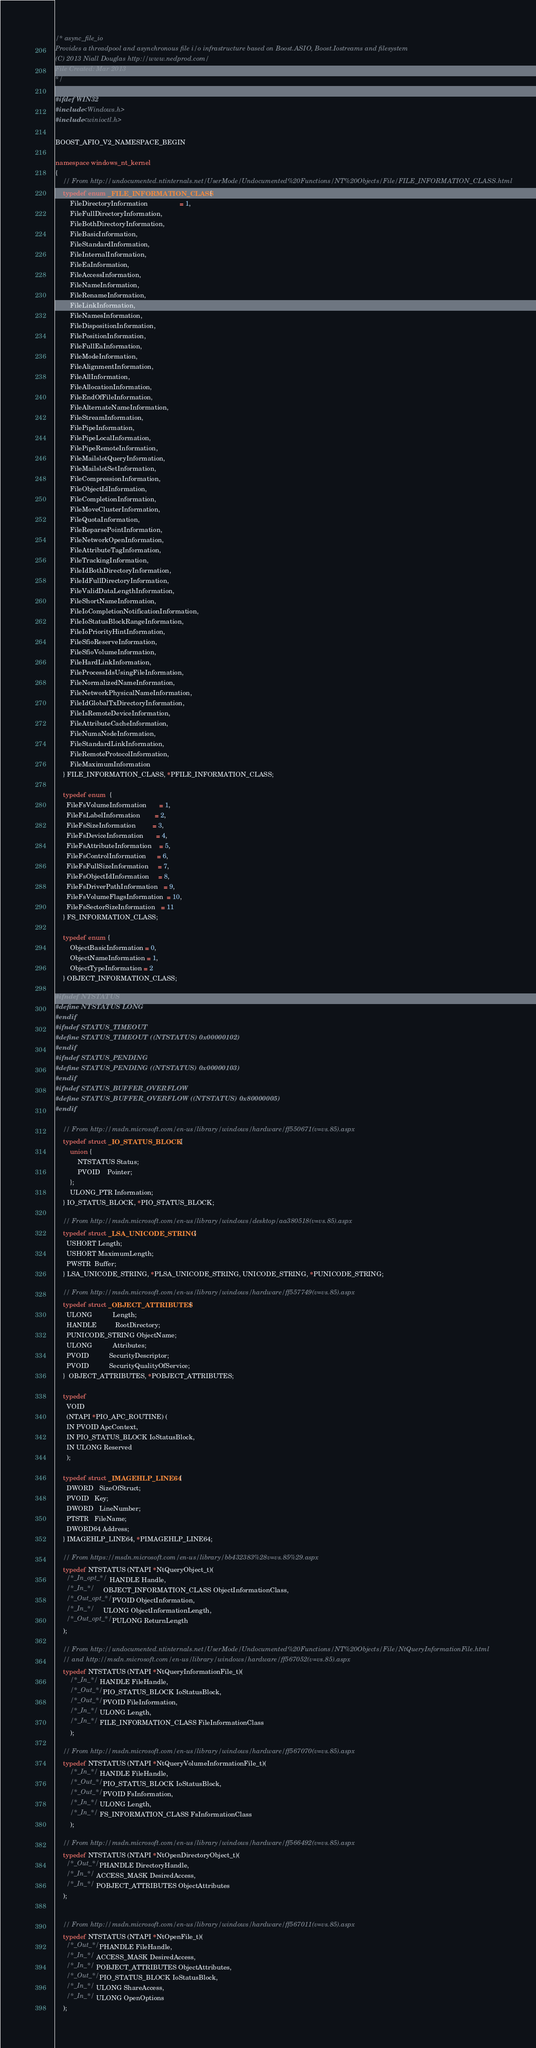Convert code to text. <code><loc_0><loc_0><loc_500><loc_500><_C++_>/* async_file_io
Provides a threadpool and asynchronous file i/o infrastructure based on Boost.ASIO, Boost.Iostreams and filesystem
(C) 2013 Niall Douglas http://www.nedprod.com/
File Created: Mar 2013
*/

#ifdef WIN32
#include <Windows.h>
#include <winioctl.h>

BOOST_AFIO_V2_NAMESPACE_BEGIN

namespace windows_nt_kernel
{
    // From http://undocumented.ntinternals.net/UserMode/Undocumented%20Functions/NT%20Objects/File/FILE_INFORMATION_CLASS.html
    typedef enum _FILE_INFORMATION_CLASS {
        FileDirectoryInformation                 = 1,
        FileFullDirectoryInformation,
        FileBothDirectoryInformation,
        FileBasicInformation,
        FileStandardInformation,
        FileInternalInformation,
        FileEaInformation,
        FileAccessInformation,
        FileNameInformation,
        FileRenameInformation,
        FileLinkInformation,
        FileNamesInformation,
        FileDispositionInformation,
        FilePositionInformation,
        FileFullEaInformation,
        FileModeInformation,
        FileAlignmentInformation,
        FileAllInformation,
        FileAllocationInformation,
        FileEndOfFileInformation,
        FileAlternateNameInformation,
        FileStreamInformation,
        FilePipeInformation,
        FilePipeLocalInformation,
        FilePipeRemoteInformation,
        FileMailslotQueryInformation,
        FileMailslotSetInformation,
        FileCompressionInformation,
        FileObjectIdInformation,
        FileCompletionInformation,
        FileMoveClusterInformation,
        FileQuotaInformation,
        FileReparsePointInformation,
        FileNetworkOpenInformation,
        FileAttributeTagInformation,
        FileTrackingInformation,
        FileIdBothDirectoryInformation,
        FileIdFullDirectoryInformation,
        FileValidDataLengthInformation,
        FileShortNameInformation,
        FileIoCompletionNotificationInformation,
        FileIoStatusBlockRangeInformation,
        FileIoPriorityHintInformation,
        FileSfioReserveInformation,
        FileSfioVolumeInformation,
        FileHardLinkInformation,
        FileProcessIdsUsingFileInformation,
        FileNormalizedNameInformation,
        FileNetworkPhysicalNameInformation,
        FileIdGlobalTxDirectoryInformation,
        FileIsRemoteDeviceInformation,
        FileAttributeCacheInformation,
        FileNumaNodeInformation,
        FileStandardLinkInformation,
        FileRemoteProtocolInformation,
        FileMaximumInformation
    } FILE_INFORMATION_CLASS, *PFILE_INFORMATION_CLASS;

    typedef enum  { 
      FileFsVolumeInformation       = 1,
      FileFsLabelInformation        = 2,
      FileFsSizeInformation         = 3,
      FileFsDeviceInformation       = 4,
      FileFsAttributeInformation    = 5,
      FileFsControlInformation      = 6,
      FileFsFullSizeInformation     = 7,
      FileFsObjectIdInformation     = 8,
      FileFsDriverPathInformation   = 9,
      FileFsVolumeFlagsInformation  = 10,
      FileFsSectorSizeInformation   = 11
    } FS_INFORMATION_CLASS;
    
    typedef enum {
        ObjectBasicInformation = 0,
        ObjectNameInformation = 1,
        ObjectTypeInformation = 2
    } OBJECT_INFORMATION_CLASS;

#ifndef NTSTATUS
#define NTSTATUS LONG
#endif
#ifndef STATUS_TIMEOUT
#define STATUS_TIMEOUT ((NTSTATUS) 0x00000102)
#endif
#ifndef STATUS_PENDING
#define STATUS_PENDING ((NTSTATUS) 0x00000103)
#endif
#ifndef STATUS_BUFFER_OVERFLOW
#define STATUS_BUFFER_OVERFLOW ((NTSTATUS) 0x80000005)
#endif

    // From http://msdn.microsoft.com/en-us/library/windows/hardware/ff550671(v=vs.85).aspx
    typedef struct _IO_STATUS_BLOCK {
        union {
            NTSTATUS Status;
            PVOID    Pointer;
        };
        ULONG_PTR Information;
    } IO_STATUS_BLOCK, *PIO_STATUS_BLOCK;

    // From http://msdn.microsoft.com/en-us/library/windows/desktop/aa380518(v=vs.85).aspx
    typedef struct _LSA_UNICODE_STRING {
      USHORT Length;
      USHORT MaximumLength;
      PWSTR  Buffer;
    } LSA_UNICODE_STRING, *PLSA_UNICODE_STRING, UNICODE_STRING, *PUNICODE_STRING;

    // From http://msdn.microsoft.com/en-us/library/windows/hardware/ff557749(v=vs.85).aspx
    typedef struct _OBJECT_ATTRIBUTES {
      ULONG           Length;
      HANDLE          RootDirectory;
      PUNICODE_STRING ObjectName;
      ULONG           Attributes;
      PVOID           SecurityDescriptor;
      PVOID           SecurityQualityOfService;
    }  OBJECT_ATTRIBUTES, *POBJECT_ATTRIBUTES;

    typedef
      VOID
      (NTAPI *PIO_APC_ROUTINE) (
      IN PVOID ApcContext,
      IN PIO_STATUS_BLOCK IoStatusBlock,
      IN ULONG Reserved
      );

    typedef struct _IMAGEHLP_LINE64 {
      DWORD   SizeOfStruct;
      PVOID   Key;
      DWORD   LineNumber;
      PTSTR   FileName;
      DWORD64 Address;
    } IMAGEHLP_LINE64, *PIMAGEHLP_LINE64;

    // From https://msdn.microsoft.com/en-us/library/bb432383%28v=vs.85%29.aspx
    typedef NTSTATUS (NTAPI *NtQueryObject_t)(
      /*_In_opt_*/   HANDLE Handle,
      /*_In_*/       OBJECT_INFORMATION_CLASS ObjectInformationClass,
      /*_Out_opt_*/  PVOID ObjectInformation,
      /*_In_*/       ULONG ObjectInformationLength,
      /*_Out_opt_*/  PULONG ReturnLength
    );
    
    // From http://undocumented.ntinternals.net/UserMode/Undocumented%20Functions/NT%20Objects/File/NtQueryInformationFile.html
    // and http://msdn.microsoft.com/en-us/library/windows/hardware/ff567052(v=vs.85).aspx
    typedef NTSTATUS (NTAPI *NtQueryInformationFile_t)(
        /*_In_*/   HANDLE FileHandle,
        /*_Out_*/  PIO_STATUS_BLOCK IoStatusBlock,
        /*_Out_*/  PVOID FileInformation,
        /*_In_*/   ULONG Length,
        /*_In_*/   FILE_INFORMATION_CLASS FileInformationClass
        );

    // From http://msdn.microsoft.com/en-us/library/windows/hardware/ff567070(v=vs.85).aspx
    typedef NTSTATUS (NTAPI *NtQueryVolumeInformationFile_t)(
        /*_In_*/   HANDLE FileHandle,
        /*_Out_*/  PIO_STATUS_BLOCK IoStatusBlock,
        /*_Out_*/  PVOID FsInformation,
        /*_In_*/   ULONG Length,
        /*_In_*/   FS_INFORMATION_CLASS FsInformationClass
        );

    // From http://msdn.microsoft.com/en-us/library/windows/hardware/ff566492(v=vs.85).aspx
    typedef NTSTATUS (NTAPI *NtOpenDirectoryObject_t)(
      /*_Out_*/  PHANDLE DirectoryHandle,
      /*_In_*/   ACCESS_MASK DesiredAccess,
      /*_In_*/   POBJECT_ATTRIBUTES ObjectAttributes
    );


    // From http://msdn.microsoft.com/en-us/library/windows/hardware/ff567011(v=vs.85).aspx
    typedef NTSTATUS (NTAPI *NtOpenFile_t)(
      /*_Out_*/  PHANDLE FileHandle,
      /*_In_*/   ACCESS_MASK DesiredAccess,
      /*_In_*/   POBJECT_ATTRIBUTES ObjectAttributes,
      /*_Out_*/  PIO_STATUS_BLOCK IoStatusBlock,
      /*_In_*/   ULONG ShareAccess,
      /*_In_*/   ULONG OpenOptions
    );
</code> 